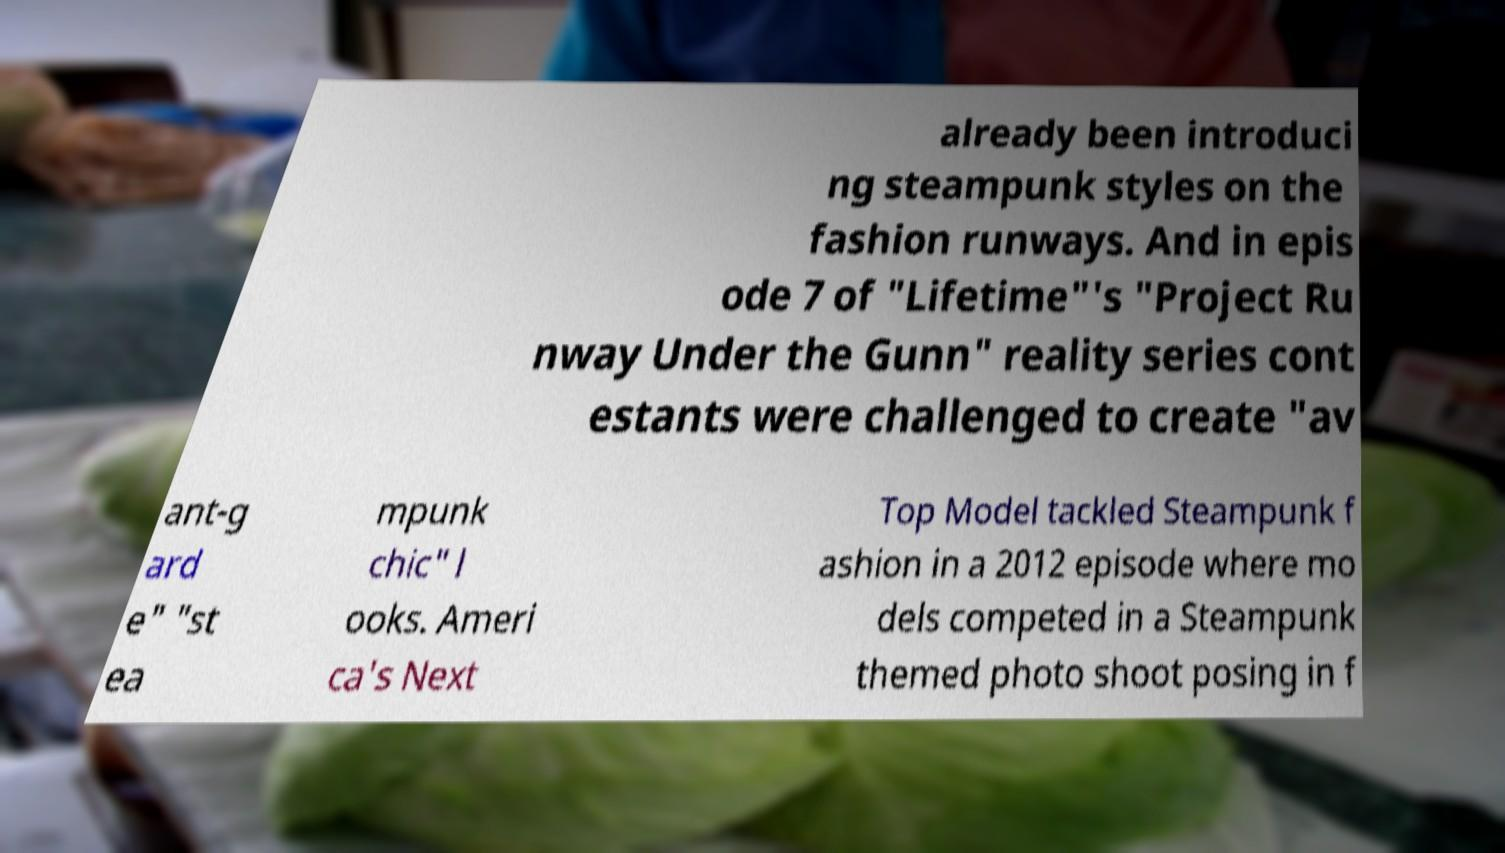There's text embedded in this image that I need extracted. Can you transcribe it verbatim? already been introduci ng steampunk styles on the fashion runways. And in epis ode 7 of "Lifetime"'s "Project Ru nway Under the Gunn" reality series cont estants were challenged to create "av ant-g ard e" "st ea mpunk chic" l ooks. Ameri ca's Next Top Model tackled Steampunk f ashion in a 2012 episode where mo dels competed in a Steampunk themed photo shoot posing in f 